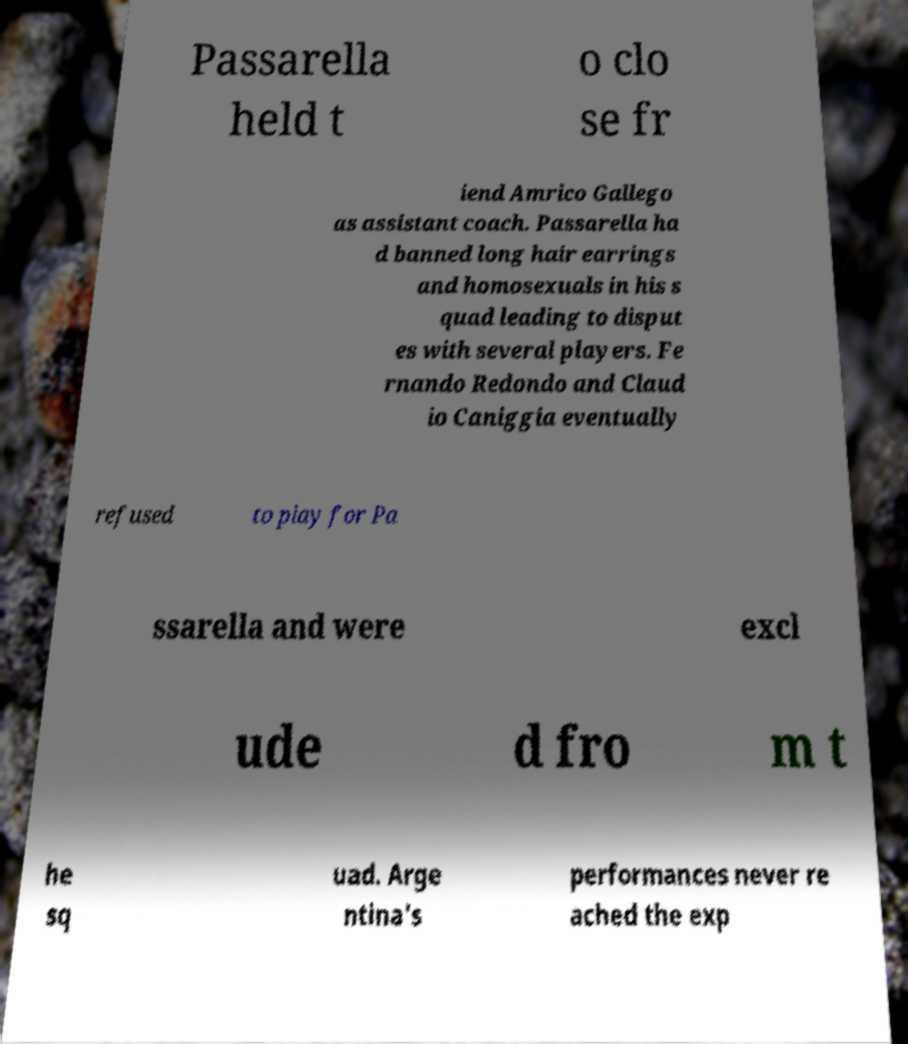Please identify and transcribe the text found in this image. Passarella held t o clo se fr iend Amrico Gallego as assistant coach. Passarella ha d banned long hair earrings and homosexuals in his s quad leading to disput es with several players. Fe rnando Redondo and Claud io Caniggia eventually refused to play for Pa ssarella and were excl ude d fro m t he sq uad. Arge ntina's performances never re ached the exp 